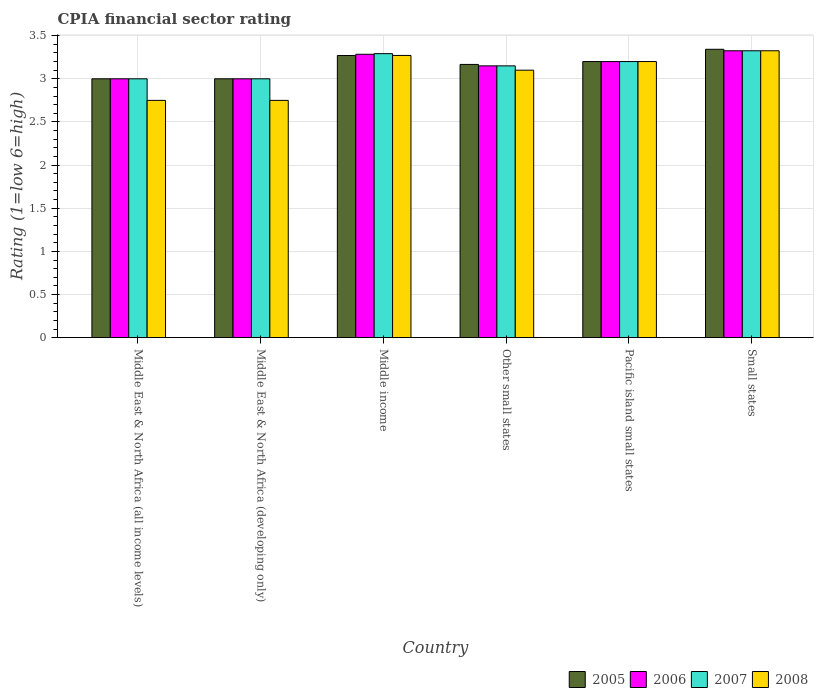How many different coloured bars are there?
Provide a succinct answer. 4. How many groups of bars are there?
Ensure brevity in your answer.  6. How many bars are there on the 4th tick from the left?
Provide a short and direct response. 4. How many bars are there on the 6th tick from the right?
Provide a succinct answer. 4. What is the label of the 1st group of bars from the left?
Your answer should be compact. Middle East & North Africa (all income levels). What is the CPIA rating in 2007 in Middle East & North Africa (all income levels)?
Give a very brief answer. 3. Across all countries, what is the maximum CPIA rating in 2005?
Ensure brevity in your answer.  3.34. Across all countries, what is the minimum CPIA rating in 2006?
Your answer should be compact. 3. In which country was the CPIA rating in 2005 maximum?
Ensure brevity in your answer.  Small states. In which country was the CPIA rating in 2008 minimum?
Your answer should be compact. Middle East & North Africa (all income levels). What is the total CPIA rating in 2008 in the graph?
Ensure brevity in your answer.  18.4. What is the difference between the CPIA rating in 2005 in Middle East & North Africa (developing only) and that in Pacific island small states?
Keep it short and to the point. -0.2. What is the difference between the CPIA rating in 2006 in Pacific island small states and the CPIA rating in 2007 in Small states?
Offer a terse response. -0.12. What is the average CPIA rating in 2005 per country?
Give a very brief answer. 3.16. What is the difference between the CPIA rating of/in 2006 and CPIA rating of/in 2007 in Middle East & North Africa (all income levels)?
Give a very brief answer. 0. What is the ratio of the CPIA rating in 2006 in Middle East & North Africa (developing only) to that in Small states?
Offer a terse response. 0.9. Is the difference between the CPIA rating in 2006 in Other small states and Small states greater than the difference between the CPIA rating in 2007 in Other small states and Small states?
Provide a succinct answer. No. What is the difference between the highest and the second highest CPIA rating in 2006?
Your response must be concise. -0.04. What is the difference between the highest and the lowest CPIA rating in 2006?
Provide a succinct answer. 0.33. In how many countries, is the CPIA rating in 2006 greater than the average CPIA rating in 2006 taken over all countries?
Your response must be concise. 3. Is the sum of the CPIA rating in 2006 in Middle East & North Africa (all income levels) and Pacific island small states greater than the maximum CPIA rating in 2007 across all countries?
Keep it short and to the point. Yes. What does the 4th bar from the right in Other small states represents?
Your answer should be very brief. 2005. Is it the case that in every country, the sum of the CPIA rating in 2006 and CPIA rating in 2008 is greater than the CPIA rating in 2005?
Offer a very short reply. Yes. How many bars are there?
Provide a succinct answer. 24. How many countries are there in the graph?
Provide a succinct answer. 6. Does the graph contain any zero values?
Offer a terse response. No. Where does the legend appear in the graph?
Your answer should be very brief. Bottom right. What is the title of the graph?
Your answer should be compact. CPIA financial sector rating. Does "1982" appear as one of the legend labels in the graph?
Your answer should be compact. No. What is the label or title of the X-axis?
Ensure brevity in your answer.  Country. What is the Rating (1=low 6=high) of 2005 in Middle East & North Africa (all income levels)?
Make the answer very short. 3. What is the Rating (1=low 6=high) in 2008 in Middle East & North Africa (all income levels)?
Your answer should be compact. 2.75. What is the Rating (1=low 6=high) of 2006 in Middle East & North Africa (developing only)?
Make the answer very short. 3. What is the Rating (1=low 6=high) in 2007 in Middle East & North Africa (developing only)?
Offer a terse response. 3. What is the Rating (1=low 6=high) in 2008 in Middle East & North Africa (developing only)?
Your response must be concise. 2.75. What is the Rating (1=low 6=high) in 2005 in Middle income?
Your answer should be compact. 3.27. What is the Rating (1=low 6=high) of 2006 in Middle income?
Provide a succinct answer. 3.28. What is the Rating (1=low 6=high) in 2007 in Middle income?
Keep it short and to the point. 3.29. What is the Rating (1=low 6=high) in 2008 in Middle income?
Ensure brevity in your answer.  3.27. What is the Rating (1=low 6=high) in 2005 in Other small states?
Provide a succinct answer. 3.17. What is the Rating (1=low 6=high) of 2006 in Other small states?
Your answer should be very brief. 3.15. What is the Rating (1=low 6=high) of 2007 in Other small states?
Keep it short and to the point. 3.15. What is the Rating (1=low 6=high) of 2008 in Other small states?
Provide a succinct answer. 3.1. What is the Rating (1=low 6=high) of 2006 in Pacific island small states?
Provide a short and direct response. 3.2. What is the Rating (1=low 6=high) of 2008 in Pacific island small states?
Provide a succinct answer. 3.2. What is the Rating (1=low 6=high) in 2005 in Small states?
Offer a terse response. 3.34. What is the Rating (1=low 6=high) of 2006 in Small states?
Keep it short and to the point. 3.33. What is the Rating (1=low 6=high) of 2007 in Small states?
Ensure brevity in your answer.  3.33. What is the Rating (1=low 6=high) of 2008 in Small states?
Make the answer very short. 3.33. Across all countries, what is the maximum Rating (1=low 6=high) in 2005?
Your answer should be compact. 3.34. Across all countries, what is the maximum Rating (1=low 6=high) of 2006?
Offer a terse response. 3.33. Across all countries, what is the maximum Rating (1=low 6=high) in 2007?
Offer a terse response. 3.33. Across all countries, what is the maximum Rating (1=low 6=high) of 2008?
Offer a terse response. 3.33. Across all countries, what is the minimum Rating (1=low 6=high) of 2006?
Provide a succinct answer. 3. Across all countries, what is the minimum Rating (1=low 6=high) in 2007?
Provide a succinct answer. 3. Across all countries, what is the minimum Rating (1=low 6=high) in 2008?
Give a very brief answer. 2.75. What is the total Rating (1=low 6=high) in 2005 in the graph?
Make the answer very short. 18.98. What is the total Rating (1=low 6=high) of 2006 in the graph?
Provide a succinct answer. 18.96. What is the total Rating (1=low 6=high) of 2007 in the graph?
Offer a terse response. 18.97. What is the total Rating (1=low 6=high) in 2008 in the graph?
Your answer should be very brief. 18.4. What is the difference between the Rating (1=low 6=high) in 2007 in Middle East & North Africa (all income levels) and that in Middle East & North Africa (developing only)?
Make the answer very short. 0. What is the difference between the Rating (1=low 6=high) in 2008 in Middle East & North Africa (all income levels) and that in Middle East & North Africa (developing only)?
Provide a succinct answer. 0. What is the difference between the Rating (1=low 6=high) of 2005 in Middle East & North Africa (all income levels) and that in Middle income?
Provide a short and direct response. -0.27. What is the difference between the Rating (1=low 6=high) of 2006 in Middle East & North Africa (all income levels) and that in Middle income?
Keep it short and to the point. -0.28. What is the difference between the Rating (1=low 6=high) of 2007 in Middle East & North Africa (all income levels) and that in Middle income?
Offer a terse response. -0.29. What is the difference between the Rating (1=low 6=high) in 2008 in Middle East & North Africa (all income levels) and that in Middle income?
Offer a very short reply. -0.52. What is the difference between the Rating (1=low 6=high) of 2006 in Middle East & North Africa (all income levels) and that in Other small states?
Your answer should be very brief. -0.15. What is the difference between the Rating (1=low 6=high) in 2008 in Middle East & North Africa (all income levels) and that in Other small states?
Your response must be concise. -0.35. What is the difference between the Rating (1=low 6=high) in 2005 in Middle East & North Africa (all income levels) and that in Pacific island small states?
Your response must be concise. -0.2. What is the difference between the Rating (1=low 6=high) of 2007 in Middle East & North Africa (all income levels) and that in Pacific island small states?
Offer a very short reply. -0.2. What is the difference between the Rating (1=low 6=high) of 2008 in Middle East & North Africa (all income levels) and that in Pacific island small states?
Offer a very short reply. -0.45. What is the difference between the Rating (1=low 6=high) in 2005 in Middle East & North Africa (all income levels) and that in Small states?
Ensure brevity in your answer.  -0.34. What is the difference between the Rating (1=low 6=high) in 2006 in Middle East & North Africa (all income levels) and that in Small states?
Provide a succinct answer. -0.33. What is the difference between the Rating (1=low 6=high) of 2007 in Middle East & North Africa (all income levels) and that in Small states?
Your answer should be very brief. -0.33. What is the difference between the Rating (1=low 6=high) of 2008 in Middle East & North Africa (all income levels) and that in Small states?
Your answer should be compact. -0.57. What is the difference between the Rating (1=low 6=high) in 2005 in Middle East & North Africa (developing only) and that in Middle income?
Provide a short and direct response. -0.27. What is the difference between the Rating (1=low 6=high) of 2006 in Middle East & North Africa (developing only) and that in Middle income?
Offer a terse response. -0.28. What is the difference between the Rating (1=low 6=high) of 2007 in Middle East & North Africa (developing only) and that in Middle income?
Offer a very short reply. -0.29. What is the difference between the Rating (1=low 6=high) in 2008 in Middle East & North Africa (developing only) and that in Middle income?
Provide a short and direct response. -0.52. What is the difference between the Rating (1=low 6=high) in 2005 in Middle East & North Africa (developing only) and that in Other small states?
Your answer should be very brief. -0.17. What is the difference between the Rating (1=low 6=high) of 2006 in Middle East & North Africa (developing only) and that in Other small states?
Your response must be concise. -0.15. What is the difference between the Rating (1=low 6=high) in 2007 in Middle East & North Africa (developing only) and that in Other small states?
Your answer should be compact. -0.15. What is the difference between the Rating (1=low 6=high) of 2008 in Middle East & North Africa (developing only) and that in Other small states?
Your answer should be compact. -0.35. What is the difference between the Rating (1=low 6=high) of 2005 in Middle East & North Africa (developing only) and that in Pacific island small states?
Provide a succinct answer. -0.2. What is the difference between the Rating (1=low 6=high) in 2006 in Middle East & North Africa (developing only) and that in Pacific island small states?
Offer a very short reply. -0.2. What is the difference between the Rating (1=low 6=high) in 2008 in Middle East & North Africa (developing only) and that in Pacific island small states?
Offer a terse response. -0.45. What is the difference between the Rating (1=low 6=high) in 2005 in Middle East & North Africa (developing only) and that in Small states?
Your response must be concise. -0.34. What is the difference between the Rating (1=low 6=high) of 2006 in Middle East & North Africa (developing only) and that in Small states?
Ensure brevity in your answer.  -0.33. What is the difference between the Rating (1=low 6=high) of 2007 in Middle East & North Africa (developing only) and that in Small states?
Your answer should be compact. -0.33. What is the difference between the Rating (1=low 6=high) of 2008 in Middle East & North Africa (developing only) and that in Small states?
Make the answer very short. -0.57. What is the difference between the Rating (1=low 6=high) in 2005 in Middle income and that in Other small states?
Provide a short and direct response. 0.1. What is the difference between the Rating (1=low 6=high) in 2006 in Middle income and that in Other small states?
Provide a short and direct response. 0.13. What is the difference between the Rating (1=low 6=high) of 2007 in Middle income and that in Other small states?
Provide a succinct answer. 0.14. What is the difference between the Rating (1=low 6=high) in 2008 in Middle income and that in Other small states?
Provide a short and direct response. 0.17. What is the difference between the Rating (1=low 6=high) in 2005 in Middle income and that in Pacific island small states?
Your answer should be very brief. 0.07. What is the difference between the Rating (1=low 6=high) of 2006 in Middle income and that in Pacific island small states?
Your response must be concise. 0.08. What is the difference between the Rating (1=low 6=high) of 2007 in Middle income and that in Pacific island small states?
Provide a succinct answer. 0.09. What is the difference between the Rating (1=low 6=high) of 2008 in Middle income and that in Pacific island small states?
Provide a short and direct response. 0.07. What is the difference between the Rating (1=low 6=high) of 2005 in Middle income and that in Small states?
Make the answer very short. -0.07. What is the difference between the Rating (1=low 6=high) in 2006 in Middle income and that in Small states?
Provide a short and direct response. -0.04. What is the difference between the Rating (1=low 6=high) in 2007 in Middle income and that in Small states?
Provide a short and direct response. -0.03. What is the difference between the Rating (1=low 6=high) of 2008 in Middle income and that in Small states?
Offer a very short reply. -0.05. What is the difference between the Rating (1=low 6=high) of 2005 in Other small states and that in Pacific island small states?
Your answer should be very brief. -0.03. What is the difference between the Rating (1=low 6=high) in 2006 in Other small states and that in Pacific island small states?
Your answer should be very brief. -0.05. What is the difference between the Rating (1=low 6=high) in 2008 in Other small states and that in Pacific island small states?
Your answer should be compact. -0.1. What is the difference between the Rating (1=low 6=high) of 2005 in Other small states and that in Small states?
Your answer should be very brief. -0.18. What is the difference between the Rating (1=low 6=high) in 2006 in Other small states and that in Small states?
Your response must be concise. -0.17. What is the difference between the Rating (1=low 6=high) in 2007 in Other small states and that in Small states?
Your answer should be very brief. -0.17. What is the difference between the Rating (1=low 6=high) of 2008 in Other small states and that in Small states?
Keep it short and to the point. -0.23. What is the difference between the Rating (1=low 6=high) of 2005 in Pacific island small states and that in Small states?
Your response must be concise. -0.14. What is the difference between the Rating (1=low 6=high) in 2006 in Pacific island small states and that in Small states?
Make the answer very short. -0.12. What is the difference between the Rating (1=low 6=high) in 2007 in Pacific island small states and that in Small states?
Your answer should be very brief. -0.12. What is the difference between the Rating (1=low 6=high) in 2008 in Pacific island small states and that in Small states?
Your response must be concise. -0.12. What is the difference between the Rating (1=low 6=high) in 2005 in Middle East & North Africa (all income levels) and the Rating (1=low 6=high) in 2006 in Middle East & North Africa (developing only)?
Your response must be concise. 0. What is the difference between the Rating (1=low 6=high) in 2006 in Middle East & North Africa (all income levels) and the Rating (1=low 6=high) in 2008 in Middle East & North Africa (developing only)?
Keep it short and to the point. 0.25. What is the difference between the Rating (1=low 6=high) in 2005 in Middle East & North Africa (all income levels) and the Rating (1=low 6=high) in 2006 in Middle income?
Give a very brief answer. -0.28. What is the difference between the Rating (1=low 6=high) in 2005 in Middle East & North Africa (all income levels) and the Rating (1=low 6=high) in 2007 in Middle income?
Ensure brevity in your answer.  -0.29. What is the difference between the Rating (1=low 6=high) of 2005 in Middle East & North Africa (all income levels) and the Rating (1=low 6=high) of 2008 in Middle income?
Provide a succinct answer. -0.27. What is the difference between the Rating (1=low 6=high) in 2006 in Middle East & North Africa (all income levels) and the Rating (1=low 6=high) in 2007 in Middle income?
Offer a very short reply. -0.29. What is the difference between the Rating (1=low 6=high) in 2006 in Middle East & North Africa (all income levels) and the Rating (1=low 6=high) in 2008 in Middle income?
Your answer should be compact. -0.27. What is the difference between the Rating (1=low 6=high) in 2007 in Middle East & North Africa (all income levels) and the Rating (1=low 6=high) in 2008 in Middle income?
Provide a succinct answer. -0.27. What is the difference between the Rating (1=low 6=high) of 2006 in Middle East & North Africa (all income levels) and the Rating (1=low 6=high) of 2008 in Other small states?
Provide a succinct answer. -0.1. What is the difference between the Rating (1=low 6=high) in 2007 in Middle East & North Africa (all income levels) and the Rating (1=low 6=high) in 2008 in Other small states?
Your response must be concise. -0.1. What is the difference between the Rating (1=low 6=high) of 2005 in Middle East & North Africa (all income levels) and the Rating (1=low 6=high) of 2006 in Pacific island small states?
Provide a succinct answer. -0.2. What is the difference between the Rating (1=low 6=high) of 2006 in Middle East & North Africa (all income levels) and the Rating (1=low 6=high) of 2007 in Pacific island small states?
Make the answer very short. -0.2. What is the difference between the Rating (1=low 6=high) in 2005 in Middle East & North Africa (all income levels) and the Rating (1=low 6=high) in 2006 in Small states?
Your answer should be compact. -0.33. What is the difference between the Rating (1=low 6=high) in 2005 in Middle East & North Africa (all income levels) and the Rating (1=low 6=high) in 2007 in Small states?
Make the answer very short. -0.33. What is the difference between the Rating (1=low 6=high) in 2005 in Middle East & North Africa (all income levels) and the Rating (1=low 6=high) in 2008 in Small states?
Keep it short and to the point. -0.33. What is the difference between the Rating (1=low 6=high) of 2006 in Middle East & North Africa (all income levels) and the Rating (1=low 6=high) of 2007 in Small states?
Offer a very short reply. -0.33. What is the difference between the Rating (1=low 6=high) in 2006 in Middle East & North Africa (all income levels) and the Rating (1=low 6=high) in 2008 in Small states?
Keep it short and to the point. -0.33. What is the difference between the Rating (1=low 6=high) in 2007 in Middle East & North Africa (all income levels) and the Rating (1=low 6=high) in 2008 in Small states?
Ensure brevity in your answer.  -0.33. What is the difference between the Rating (1=low 6=high) in 2005 in Middle East & North Africa (developing only) and the Rating (1=low 6=high) in 2006 in Middle income?
Make the answer very short. -0.28. What is the difference between the Rating (1=low 6=high) in 2005 in Middle East & North Africa (developing only) and the Rating (1=low 6=high) in 2007 in Middle income?
Ensure brevity in your answer.  -0.29. What is the difference between the Rating (1=low 6=high) of 2005 in Middle East & North Africa (developing only) and the Rating (1=low 6=high) of 2008 in Middle income?
Offer a very short reply. -0.27. What is the difference between the Rating (1=low 6=high) of 2006 in Middle East & North Africa (developing only) and the Rating (1=low 6=high) of 2007 in Middle income?
Provide a succinct answer. -0.29. What is the difference between the Rating (1=low 6=high) of 2006 in Middle East & North Africa (developing only) and the Rating (1=low 6=high) of 2008 in Middle income?
Give a very brief answer. -0.27. What is the difference between the Rating (1=low 6=high) of 2007 in Middle East & North Africa (developing only) and the Rating (1=low 6=high) of 2008 in Middle income?
Your answer should be compact. -0.27. What is the difference between the Rating (1=low 6=high) in 2005 in Middle East & North Africa (developing only) and the Rating (1=low 6=high) in 2006 in Other small states?
Provide a short and direct response. -0.15. What is the difference between the Rating (1=low 6=high) of 2005 in Middle East & North Africa (developing only) and the Rating (1=low 6=high) of 2007 in Other small states?
Your response must be concise. -0.15. What is the difference between the Rating (1=low 6=high) of 2006 in Middle East & North Africa (developing only) and the Rating (1=low 6=high) of 2007 in Other small states?
Offer a very short reply. -0.15. What is the difference between the Rating (1=low 6=high) of 2005 in Middle East & North Africa (developing only) and the Rating (1=low 6=high) of 2007 in Pacific island small states?
Give a very brief answer. -0.2. What is the difference between the Rating (1=low 6=high) in 2005 in Middle East & North Africa (developing only) and the Rating (1=low 6=high) in 2008 in Pacific island small states?
Provide a short and direct response. -0.2. What is the difference between the Rating (1=low 6=high) of 2005 in Middle East & North Africa (developing only) and the Rating (1=low 6=high) of 2006 in Small states?
Your answer should be compact. -0.33. What is the difference between the Rating (1=low 6=high) in 2005 in Middle East & North Africa (developing only) and the Rating (1=low 6=high) in 2007 in Small states?
Provide a short and direct response. -0.33. What is the difference between the Rating (1=low 6=high) in 2005 in Middle East & North Africa (developing only) and the Rating (1=low 6=high) in 2008 in Small states?
Your response must be concise. -0.33. What is the difference between the Rating (1=low 6=high) of 2006 in Middle East & North Africa (developing only) and the Rating (1=low 6=high) of 2007 in Small states?
Provide a succinct answer. -0.33. What is the difference between the Rating (1=low 6=high) of 2006 in Middle East & North Africa (developing only) and the Rating (1=low 6=high) of 2008 in Small states?
Make the answer very short. -0.33. What is the difference between the Rating (1=low 6=high) of 2007 in Middle East & North Africa (developing only) and the Rating (1=low 6=high) of 2008 in Small states?
Keep it short and to the point. -0.33. What is the difference between the Rating (1=low 6=high) of 2005 in Middle income and the Rating (1=low 6=high) of 2006 in Other small states?
Offer a terse response. 0.12. What is the difference between the Rating (1=low 6=high) in 2005 in Middle income and the Rating (1=low 6=high) in 2007 in Other small states?
Keep it short and to the point. 0.12. What is the difference between the Rating (1=low 6=high) in 2005 in Middle income and the Rating (1=low 6=high) in 2008 in Other small states?
Your answer should be very brief. 0.17. What is the difference between the Rating (1=low 6=high) in 2006 in Middle income and the Rating (1=low 6=high) in 2007 in Other small states?
Provide a short and direct response. 0.13. What is the difference between the Rating (1=low 6=high) in 2006 in Middle income and the Rating (1=low 6=high) in 2008 in Other small states?
Ensure brevity in your answer.  0.18. What is the difference between the Rating (1=low 6=high) in 2007 in Middle income and the Rating (1=low 6=high) in 2008 in Other small states?
Provide a succinct answer. 0.19. What is the difference between the Rating (1=low 6=high) of 2005 in Middle income and the Rating (1=low 6=high) of 2006 in Pacific island small states?
Ensure brevity in your answer.  0.07. What is the difference between the Rating (1=low 6=high) of 2005 in Middle income and the Rating (1=low 6=high) of 2007 in Pacific island small states?
Your answer should be compact. 0.07. What is the difference between the Rating (1=low 6=high) of 2005 in Middle income and the Rating (1=low 6=high) of 2008 in Pacific island small states?
Ensure brevity in your answer.  0.07. What is the difference between the Rating (1=low 6=high) in 2006 in Middle income and the Rating (1=low 6=high) in 2007 in Pacific island small states?
Keep it short and to the point. 0.08. What is the difference between the Rating (1=low 6=high) in 2006 in Middle income and the Rating (1=low 6=high) in 2008 in Pacific island small states?
Give a very brief answer. 0.08. What is the difference between the Rating (1=low 6=high) in 2007 in Middle income and the Rating (1=low 6=high) in 2008 in Pacific island small states?
Provide a succinct answer. 0.09. What is the difference between the Rating (1=low 6=high) of 2005 in Middle income and the Rating (1=low 6=high) of 2006 in Small states?
Ensure brevity in your answer.  -0.06. What is the difference between the Rating (1=low 6=high) of 2005 in Middle income and the Rating (1=low 6=high) of 2007 in Small states?
Ensure brevity in your answer.  -0.06. What is the difference between the Rating (1=low 6=high) in 2005 in Middle income and the Rating (1=low 6=high) in 2008 in Small states?
Keep it short and to the point. -0.06. What is the difference between the Rating (1=low 6=high) in 2006 in Middle income and the Rating (1=low 6=high) in 2007 in Small states?
Offer a very short reply. -0.04. What is the difference between the Rating (1=low 6=high) in 2006 in Middle income and the Rating (1=low 6=high) in 2008 in Small states?
Make the answer very short. -0.04. What is the difference between the Rating (1=low 6=high) in 2007 in Middle income and the Rating (1=low 6=high) in 2008 in Small states?
Your response must be concise. -0.03. What is the difference between the Rating (1=low 6=high) of 2005 in Other small states and the Rating (1=low 6=high) of 2006 in Pacific island small states?
Provide a succinct answer. -0.03. What is the difference between the Rating (1=low 6=high) in 2005 in Other small states and the Rating (1=low 6=high) in 2007 in Pacific island small states?
Provide a succinct answer. -0.03. What is the difference between the Rating (1=low 6=high) of 2005 in Other small states and the Rating (1=low 6=high) of 2008 in Pacific island small states?
Provide a succinct answer. -0.03. What is the difference between the Rating (1=low 6=high) of 2006 in Other small states and the Rating (1=low 6=high) of 2008 in Pacific island small states?
Give a very brief answer. -0.05. What is the difference between the Rating (1=low 6=high) of 2007 in Other small states and the Rating (1=low 6=high) of 2008 in Pacific island small states?
Your response must be concise. -0.05. What is the difference between the Rating (1=low 6=high) in 2005 in Other small states and the Rating (1=low 6=high) in 2006 in Small states?
Your response must be concise. -0.16. What is the difference between the Rating (1=low 6=high) in 2005 in Other small states and the Rating (1=low 6=high) in 2007 in Small states?
Offer a terse response. -0.16. What is the difference between the Rating (1=low 6=high) of 2005 in Other small states and the Rating (1=low 6=high) of 2008 in Small states?
Make the answer very short. -0.16. What is the difference between the Rating (1=low 6=high) of 2006 in Other small states and the Rating (1=low 6=high) of 2007 in Small states?
Your answer should be compact. -0.17. What is the difference between the Rating (1=low 6=high) in 2006 in Other small states and the Rating (1=low 6=high) in 2008 in Small states?
Provide a succinct answer. -0.17. What is the difference between the Rating (1=low 6=high) of 2007 in Other small states and the Rating (1=low 6=high) of 2008 in Small states?
Give a very brief answer. -0.17. What is the difference between the Rating (1=low 6=high) in 2005 in Pacific island small states and the Rating (1=low 6=high) in 2006 in Small states?
Keep it short and to the point. -0.12. What is the difference between the Rating (1=low 6=high) in 2005 in Pacific island small states and the Rating (1=low 6=high) in 2007 in Small states?
Your response must be concise. -0.12. What is the difference between the Rating (1=low 6=high) of 2005 in Pacific island small states and the Rating (1=low 6=high) of 2008 in Small states?
Provide a succinct answer. -0.12. What is the difference between the Rating (1=low 6=high) of 2006 in Pacific island small states and the Rating (1=low 6=high) of 2007 in Small states?
Provide a short and direct response. -0.12. What is the difference between the Rating (1=low 6=high) of 2006 in Pacific island small states and the Rating (1=low 6=high) of 2008 in Small states?
Keep it short and to the point. -0.12. What is the difference between the Rating (1=low 6=high) in 2007 in Pacific island small states and the Rating (1=low 6=high) in 2008 in Small states?
Your answer should be compact. -0.12. What is the average Rating (1=low 6=high) in 2005 per country?
Provide a short and direct response. 3.16. What is the average Rating (1=low 6=high) of 2006 per country?
Keep it short and to the point. 3.16. What is the average Rating (1=low 6=high) of 2007 per country?
Your response must be concise. 3.16. What is the average Rating (1=low 6=high) in 2008 per country?
Your answer should be compact. 3.07. What is the difference between the Rating (1=low 6=high) of 2005 and Rating (1=low 6=high) of 2006 in Middle East & North Africa (all income levels)?
Provide a short and direct response. 0. What is the difference between the Rating (1=low 6=high) of 2005 and Rating (1=low 6=high) of 2007 in Middle East & North Africa (all income levels)?
Your response must be concise. 0. What is the difference between the Rating (1=low 6=high) in 2005 and Rating (1=low 6=high) in 2008 in Middle East & North Africa (all income levels)?
Provide a succinct answer. 0.25. What is the difference between the Rating (1=low 6=high) in 2006 and Rating (1=low 6=high) in 2008 in Middle East & North Africa (all income levels)?
Your answer should be very brief. 0.25. What is the difference between the Rating (1=low 6=high) in 2007 and Rating (1=low 6=high) in 2008 in Middle East & North Africa (all income levels)?
Offer a terse response. 0.25. What is the difference between the Rating (1=low 6=high) of 2005 and Rating (1=low 6=high) of 2006 in Middle East & North Africa (developing only)?
Keep it short and to the point. 0. What is the difference between the Rating (1=low 6=high) in 2006 and Rating (1=low 6=high) in 2007 in Middle East & North Africa (developing only)?
Offer a very short reply. 0. What is the difference between the Rating (1=low 6=high) in 2005 and Rating (1=low 6=high) in 2006 in Middle income?
Give a very brief answer. -0.01. What is the difference between the Rating (1=low 6=high) of 2005 and Rating (1=low 6=high) of 2007 in Middle income?
Your answer should be very brief. -0.02. What is the difference between the Rating (1=low 6=high) in 2005 and Rating (1=low 6=high) in 2008 in Middle income?
Your answer should be very brief. -0. What is the difference between the Rating (1=low 6=high) in 2006 and Rating (1=low 6=high) in 2007 in Middle income?
Your answer should be very brief. -0.01. What is the difference between the Rating (1=low 6=high) of 2006 and Rating (1=low 6=high) of 2008 in Middle income?
Your answer should be compact. 0.01. What is the difference between the Rating (1=low 6=high) in 2007 and Rating (1=low 6=high) in 2008 in Middle income?
Your response must be concise. 0.02. What is the difference between the Rating (1=low 6=high) in 2005 and Rating (1=low 6=high) in 2006 in Other small states?
Offer a very short reply. 0.02. What is the difference between the Rating (1=low 6=high) in 2005 and Rating (1=low 6=high) in 2007 in Other small states?
Give a very brief answer. 0.02. What is the difference between the Rating (1=low 6=high) in 2005 and Rating (1=low 6=high) in 2008 in Other small states?
Give a very brief answer. 0.07. What is the difference between the Rating (1=low 6=high) of 2006 and Rating (1=low 6=high) of 2008 in Other small states?
Your answer should be very brief. 0.05. What is the difference between the Rating (1=low 6=high) of 2007 and Rating (1=low 6=high) of 2008 in Other small states?
Offer a very short reply. 0.05. What is the difference between the Rating (1=low 6=high) of 2005 and Rating (1=low 6=high) of 2006 in Pacific island small states?
Make the answer very short. 0. What is the difference between the Rating (1=low 6=high) in 2005 and Rating (1=low 6=high) in 2006 in Small states?
Offer a terse response. 0.02. What is the difference between the Rating (1=low 6=high) of 2005 and Rating (1=low 6=high) of 2007 in Small states?
Give a very brief answer. 0.02. What is the difference between the Rating (1=low 6=high) of 2005 and Rating (1=low 6=high) of 2008 in Small states?
Offer a very short reply. 0.02. What is the difference between the Rating (1=low 6=high) in 2006 and Rating (1=low 6=high) in 2008 in Small states?
Provide a short and direct response. 0. What is the difference between the Rating (1=low 6=high) of 2007 and Rating (1=low 6=high) of 2008 in Small states?
Offer a terse response. 0. What is the ratio of the Rating (1=low 6=high) of 2005 in Middle East & North Africa (all income levels) to that in Middle East & North Africa (developing only)?
Offer a terse response. 1. What is the ratio of the Rating (1=low 6=high) of 2006 in Middle East & North Africa (all income levels) to that in Middle East & North Africa (developing only)?
Provide a short and direct response. 1. What is the ratio of the Rating (1=low 6=high) in 2007 in Middle East & North Africa (all income levels) to that in Middle East & North Africa (developing only)?
Your response must be concise. 1. What is the ratio of the Rating (1=low 6=high) in 2008 in Middle East & North Africa (all income levels) to that in Middle East & North Africa (developing only)?
Provide a short and direct response. 1. What is the ratio of the Rating (1=low 6=high) of 2005 in Middle East & North Africa (all income levels) to that in Middle income?
Provide a short and direct response. 0.92. What is the ratio of the Rating (1=low 6=high) in 2006 in Middle East & North Africa (all income levels) to that in Middle income?
Offer a terse response. 0.91. What is the ratio of the Rating (1=low 6=high) of 2007 in Middle East & North Africa (all income levels) to that in Middle income?
Make the answer very short. 0.91. What is the ratio of the Rating (1=low 6=high) of 2008 in Middle East & North Africa (all income levels) to that in Middle income?
Your answer should be very brief. 0.84. What is the ratio of the Rating (1=low 6=high) of 2006 in Middle East & North Africa (all income levels) to that in Other small states?
Provide a short and direct response. 0.95. What is the ratio of the Rating (1=low 6=high) of 2008 in Middle East & North Africa (all income levels) to that in Other small states?
Keep it short and to the point. 0.89. What is the ratio of the Rating (1=low 6=high) of 2007 in Middle East & North Africa (all income levels) to that in Pacific island small states?
Make the answer very short. 0.94. What is the ratio of the Rating (1=low 6=high) of 2008 in Middle East & North Africa (all income levels) to that in Pacific island small states?
Offer a very short reply. 0.86. What is the ratio of the Rating (1=low 6=high) of 2005 in Middle East & North Africa (all income levels) to that in Small states?
Provide a short and direct response. 0.9. What is the ratio of the Rating (1=low 6=high) of 2006 in Middle East & North Africa (all income levels) to that in Small states?
Keep it short and to the point. 0.9. What is the ratio of the Rating (1=low 6=high) of 2007 in Middle East & North Africa (all income levels) to that in Small states?
Your answer should be compact. 0.9. What is the ratio of the Rating (1=low 6=high) in 2008 in Middle East & North Africa (all income levels) to that in Small states?
Ensure brevity in your answer.  0.83. What is the ratio of the Rating (1=low 6=high) in 2005 in Middle East & North Africa (developing only) to that in Middle income?
Make the answer very short. 0.92. What is the ratio of the Rating (1=low 6=high) of 2006 in Middle East & North Africa (developing only) to that in Middle income?
Provide a succinct answer. 0.91. What is the ratio of the Rating (1=low 6=high) of 2007 in Middle East & North Africa (developing only) to that in Middle income?
Your response must be concise. 0.91. What is the ratio of the Rating (1=low 6=high) of 2008 in Middle East & North Africa (developing only) to that in Middle income?
Make the answer very short. 0.84. What is the ratio of the Rating (1=low 6=high) of 2005 in Middle East & North Africa (developing only) to that in Other small states?
Keep it short and to the point. 0.95. What is the ratio of the Rating (1=low 6=high) in 2006 in Middle East & North Africa (developing only) to that in Other small states?
Ensure brevity in your answer.  0.95. What is the ratio of the Rating (1=low 6=high) of 2007 in Middle East & North Africa (developing only) to that in Other small states?
Give a very brief answer. 0.95. What is the ratio of the Rating (1=low 6=high) of 2008 in Middle East & North Africa (developing only) to that in Other small states?
Ensure brevity in your answer.  0.89. What is the ratio of the Rating (1=low 6=high) in 2005 in Middle East & North Africa (developing only) to that in Pacific island small states?
Provide a succinct answer. 0.94. What is the ratio of the Rating (1=low 6=high) of 2008 in Middle East & North Africa (developing only) to that in Pacific island small states?
Give a very brief answer. 0.86. What is the ratio of the Rating (1=low 6=high) of 2005 in Middle East & North Africa (developing only) to that in Small states?
Give a very brief answer. 0.9. What is the ratio of the Rating (1=low 6=high) in 2006 in Middle East & North Africa (developing only) to that in Small states?
Make the answer very short. 0.9. What is the ratio of the Rating (1=low 6=high) in 2007 in Middle East & North Africa (developing only) to that in Small states?
Provide a succinct answer. 0.9. What is the ratio of the Rating (1=low 6=high) of 2008 in Middle East & North Africa (developing only) to that in Small states?
Your answer should be compact. 0.83. What is the ratio of the Rating (1=low 6=high) in 2005 in Middle income to that in Other small states?
Offer a very short reply. 1.03. What is the ratio of the Rating (1=low 6=high) of 2006 in Middle income to that in Other small states?
Ensure brevity in your answer.  1.04. What is the ratio of the Rating (1=low 6=high) in 2007 in Middle income to that in Other small states?
Make the answer very short. 1.04. What is the ratio of the Rating (1=low 6=high) in 2008 in Middle income to that in Other small states?
Make the answer very short. 1.06. What is the ratio of the Rating (1=low 6=high) of 2005 in Middle income to that in Pacific island small states?
Offer a very short reply. 1.02. What is the ratio of the Rating (1=low 6=high) in 2006 in Middle income to that in Pacific island small states?
Your response must be concise. 1.03. What is the ratio of the Rating (1=low 6=high) in 2007 in Middle income to that in Pacific island small states?
Keep it short and to the point. 1.03. What is the ratio of the Rating (1=low 6=high) in 2008 in Middle income to that in Pacific island small states?
Offer a terse response. 1.02. What is the ratio of the Rating (1=low 6=high) in 2005 in Middle income to that in Small states?
Offer a terse response. 0.98. What is the ratio of the Rating (1=low 6=high) in 2007 in Middle income to that in Small states?
Your answer should be compact. 0.99. What is the ratio of the Rating (1=low 6=high) of 2008 in Middle income to that in Small states?
Offer a very short reply. 0.98. What is the ratio of the Rating (1=low 6=high) in 2006 in Other small states to that in Pacific island small states?
Ensure brevity in your answer.  0.98. What is the ratio of the Rating (1=low 6=high) of 2007 in Other small states to that in Pacific island small states?
Offer a terse response. 0.98. What is the ratio of the Rating (1=low 6=high) of 2008 in Other small states to that in Pacific island small states?
Your answer should be compact. 0.97. What is the ratio of the Rating (1=low 6=high) of 2005 in Other small states to that in Small states?
Your response must be concise. 0.95. What is the ratio of the Rating (1=low 6=high) in 2007 in Other small states to that in Small states?
Your response must be concise. 0.95. What is the ratio of the Rating (1=low 6=high) of 2008 in Other small states to that in Small states?
Provide a short and direct response. 0.93. What is the ratio of the Rating (1=low 6=high) of 2005 in Pacific island small states to that in Small states?
Offer a very short reply. 0.96. What is the ratio of the Rating (1=low 6=high) in 2006 in Pacific island small states to that in Small states?
Give a very brief answer. 0.96. What is the ratio of the Rating (1=low 6=high) of 2007 in Pacific island small states to that in Small states?
Make the answer very short. 0.96. What is the ratio of the Rating (1=low 6=high) in 2008 in Pacific island small states to that in Small states?
Provide a short and direct response. 0.96. What is the difference between the highest and the second highest Rating (1=low 6=high) of 2005?
Give a very brief answer. 0.07. What is the difference between the highest and the second highest Rating (1=low 6=high) in 2006?
Keep it short and to the point. 0.04. What is the difference between the highest and the second highest Rating (1=low 6=high) of 2007?
Provide a short and direct response. 0.03. What is the difference between the highest and the second highest Rating (1=low 6=high) in 2008?
Make the answer very short. 0.05. What is the difference between the highest and the lowest Rating (1=low 6=high) in 2005?
Provide a succinct answer. 0.34. What is the difference between the highest and the lowest Rating (1=low 6=high) of 2006?
Your answer should be very brief. 0.33. What is the difference between the highest and the lowest Rating (1=low 6=high) of 2007?
Ensure brevity in your answer.  0.33. What is the difference between the highest and the lowest Rating (1=low 6=high) of 2008?
Keep it short and to the point. 0.57. 